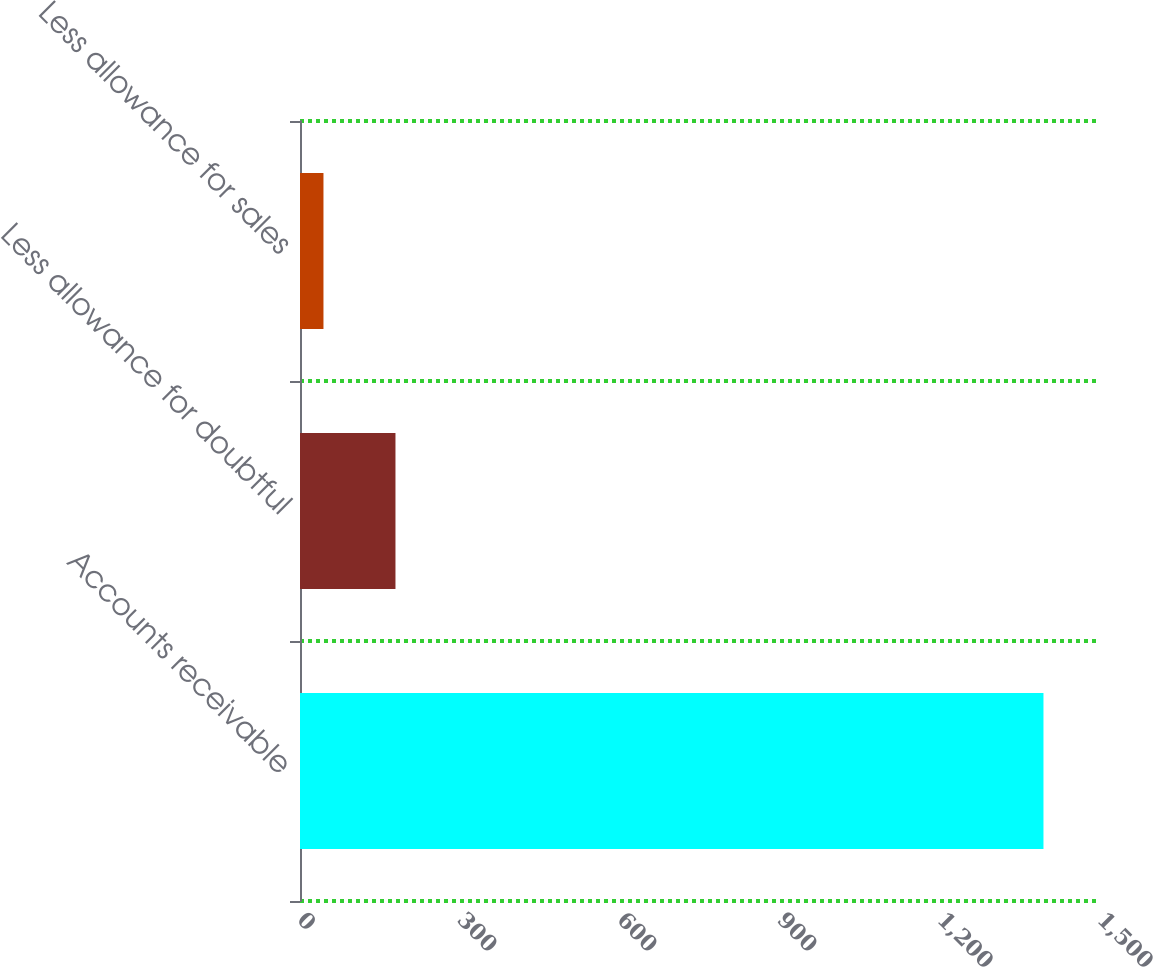<chart> <loc_0><loc_0><loc_500><loc_500><bar_chart><fcel>Accounts receivable<fcel>Less allowance for doubtful<fcel>Less allowance for sales<nl><fcel>1394<fcel>179<fcel>44<nl></chart> 